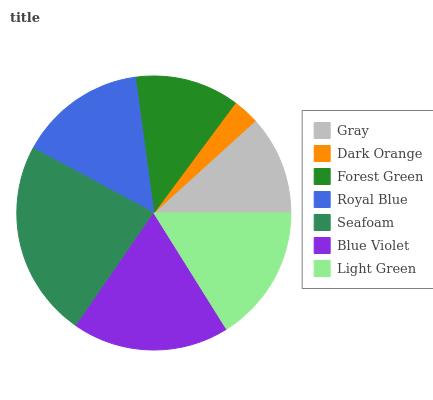Is Dark Orange the minimum?
Answer yes or no. Yes. Is Seafoam the maximum?
Answer yes or no. Yes. Is Forest Green the minimum?
Answer yes or no. No. Is Forest Green the maximum?
Answer yes or no. No. Is Forest Green greater than Dark Orange?
Answer yes or no. Yes. Is Dark Orange less than Forest Green?
Answer yes or no. Yes. Is Dark Orange greater than Forest Green?
Answer yes or no. No. Is Forest Green less than Dark Orange?
Answer yes or no. No. Is Royal Blue the high median?
Answer yes or no. Yes. Is Royal Blue the low median?
Answer yes or no. Yes. Is Seafoam the high median?
Answer yes or no. No. Is Light Green the low median?
Answer yes or no. No. 